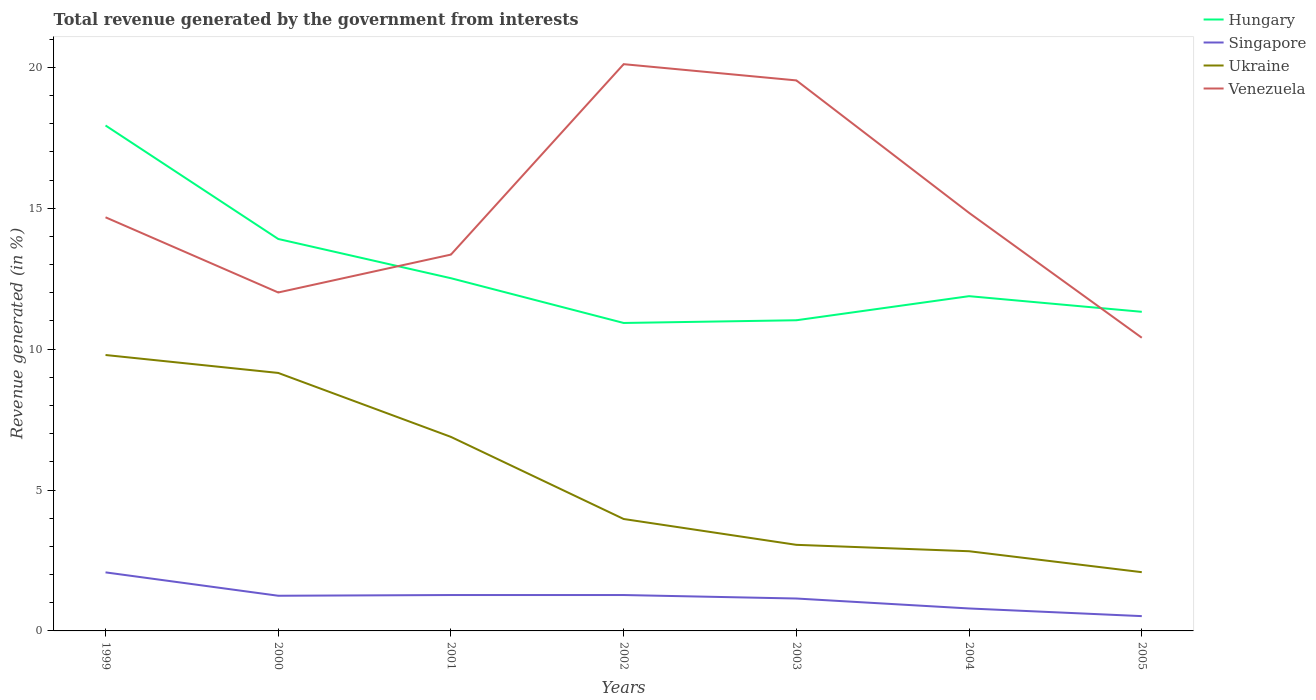How many different coloured lines are there?
Provide a succinct answer. 4. Is the number of lines equal to the number of legend labels?
Provide a succinct answer. Yes. Across all years, what is the maximum total revenue generated in Venezuela?
Ensure brevity in your answer.  10.4. In which year was the total revenue generated in Venezuela maximum?
Offer a terse response. 2005. What is the total total revenue generated in Singapore in the graph?
Keep it short and to the point. 0.35. What is the difference between the highest and the second highest total revenue generated in Ukraine?
Make the answer very short. 7.71. Is the total revenue generated in Singapore strictly greater than the total revenue generated in Hungary over the years?
Ensure brevity in your answer.  Yes. What is the difference between two consecutive major ticks on the Y-axis?
Make the answer very short. 5. Does the graph contain any zero values?
Provide a short and direct response. No. Does the graph contain grids?
Your answer should be compact. No. How many legend labels are there?
Offer a terse response. 4. What is the title of the graph?
Give a very brief answer. Total revenue generated by the government from interests. Does "Zambia" appear as one of the legend labels in the graph?
Your answer should be compact. No. What is the label or title of the Y-axis?
Your answer should be very brief. Revenue generated (in %). What is the Revenue generated (in %) of Hungary in 1999?
Offer a terse response. 17.94. What is the Revenue generated (in %) of Singapore in 1999?
Give a very brief answer. 2.08. What is the Revenue generated (in %) in Ukraine in 1999?
Your answer should be very brief. 9.79. What is the Revenue generated (in %) in Venezuela in 1999?
Your answer should be compact. 14.68. What is the Revenue generated (in %) of Hungary in 2000?
Give a very brief answer. 13.91. What is the Revenue generated (in %) in Singapore in 2000?
Provide a short and direct response. 1.25. What is the Revenue generated (in %) of Ukraine in 2000?
Ensure brevity in your answer.  9.15. What is the Revenue generated (in %) in Venezuela in 2000?
Keep it short and to the point. 12.01. What is the Revenue generated (in %) in Hungary in 2001?
Your answer should be very brief. 12.52. What is the Revenue generated (in %) of Singapore in 2001?
Offer a terse response. 1.27. What is the Revenue generated (in %) of Ukraine in 2001?
Give a very brief answer. 6.88. What is the Revenue generated (in %) of Venezuela in 2001?
Your answer should be compact. 13.35. What is the Revenue generated (in %) in Hungary in 2002?
Make the answer very short. 10.93. What is the Revenue generated (in %) in Singapore in 2002?
Offer a very short reply. 1.27. What is the Revenue generated (in %) in Ukraine in 2002?
Give a very brief answer. 3.97. What is the Revenue generated (in %) of Venezuela in 2002?
Give a very brief answer. 20.11. What is the Revenue generated (in %) in Hungary in 2003?
Keep it short and to the point. 11.02. What is the Revenue generated (in %) in Singapore in 2003?
Make the answer very short. 1.15. What is the Revenue generated (in %) in Ukraine in 2003?
Make the answer very short. 3.05. What is the Revenue generated (in %) of Venezuela in 2003?
Offer a terse response. 19.54. What is the Revenue generated (in %) in Hungary in 2004?
Your answer should be compact. 11.88. What is the Revenue generated (in %) in Singapore in 2004?
Make the answer very short. 0.8. What is the Revenue generated (in %) in Ukraine in 2004?
Your answer should be compact. 2.83. What is the Revenue generated (in %) of Venezuela in 2004?
Provide a succinct answer. 14.83. What is the Revenue generated (in %) in Hungary in 2005?
Provide a short and direct response. 11.32. What is the Revenue generated (in %) of Singapore in 2005?
Provide a short and direct response. 0.53. What is the Revenue generated (in %) of Ukraine in 2005?
Provide a succinct answer. 2.08. What is the Revenue generated (in %) in Venezuela in 2005?
Provide a short and direct response. 10.4. Across all years, what is the maximum Revenue generated (in %) of Hungary?
Provide a succinct answer. 17.94. Across all years, what is the maximum Revenue generated (in %) of Singapore?
Offer a very short reply. 2.08. Across all years, what is the maximum Revenue generated (in %) of Ukraine?
Offer a terse response. 9.79. Across all years, what is the maximum Revenue generated (in %) of Venezuela?
Offer a terse response. 20.11. Across all years, what is the minimum Revenue generated (in %) of Hungary?
Provide a succinct answer. 10.93. Across all years, what is the minimum Revenue generated (in %) of Singapore?
Your answer should be very brief. 0.53. Across all years, what is the minimum Revenue generated (in %) in Ukraine?
Your response must be concise. 2.08. Across all years, what is the minimum Revenue generated (in %) of Venezuela?
Keep it short and to the point. 10.4. What is the total Revenue generated (in %) in Hungary in the graph?
Offer a very short reply. 89.52. What is the total Revenue generated (in %) in Singapore in the graph?
Provide a succinct answer. 8.35. What is the total Revenue generated (in %) of Ukraine in the graph?
Your response must be concise. 37.77. What is the total Revenue generated (in %) of Venezuela in the graph?
Make the answer very short. 104.93. What is the difference between the Revenue generated (in %) of Hungary in 1999 and that in 2000?
Offer a terse response. 4.03. What is the difference between the Revenue generated (in %) in Singapore in 1999 and that in 2000?
Ensure brevity in your answer.  0.83. What is the difference between the Revenue generated (in %) in Ukraine in 1999 and that in 2000?
Ensure brevity in your answer.  0.64. What is the difference between the Revenue generated (in %) of Venezuela in 1999 and that in 2000?
Provide a succinct answer. 2.67. What is the difference between the Revenue generated (in %) in Hungary in 1999 and that in 2001?
Offer a very short reply. 5.42. What is the difference between the Revenue generated (in %) in Singapore in 1999 and that in 2001?
Ensure brevity in your answer.  0.8. What is the difference between the Revenue generated (in %) in Ukraine in 1999 and that in 2001?
Provide a succinct answer. 2.91. What is the difference between the Revenue generated (in %) of Venezuela in 1999 and that in 2001?
Make the answer very short. 1.32. What is the difference between the Revenue generated (in %) of Hungary in 1999 and that in 2002?
Your answer should be very brief. 7.01. What is the difference between the Revenue generated (in %) of Singapore in 1999 and that in 2002?
Offer a terse response. 0.8. What is the difference between the Revenue generated (in %) of Ukraine in 1999 and that in 2002?
Your answer should be very brief. 5.82. What is the difference between the Revenue generated (in %) in Venezuela in 1999 and that in 2002?
Provide a succinct answer. -5.43. What is the difference between the Revenue generated (in %) in Hungary in 1999 and that in 2003?
Your answer should be compact. 6.91. What is the difference between the Revenue generated (in %) in Singapore in 1999 and that in 2003?
Keep it short and to the point. 0.93. What is the difference between the Revenue generated (in %) of Ukraine in 1999 and that in 2003?
Offer a very short reply. 6.74. What is the difference between the Revenue generated (in %) in Venezuela in 1999 and that in 2003?
Provide a short and direct response. -4.86. What is the difference between the Revenue generated (in %) in Hungary in 1999 and that in 2004?
Give a very brief answer. 6.06. What is the difference between the Revenue generated (in %) in Singapore in 1999 and that in 2004?
Make the answer very short. 1.28. What is the difference between the Revenue generated (in %) in Ukraine in 1999 and that in 2004?
Keep it short and to the point. 6.96. What is the difference between the Revenue generated (in %) of Venezuela in 1999 and that in 2004?
Ensure brevity in your answer.  -0.16. What is the difference between the Revenue generated (in %) in Hungary in 1999 and that in 2005?
Make the answer very short. 6.61. What is the difference between the Revenue generated (in %) of Singapore in 1999 and that in 2005?
Make the answer very short. 1.55. What is the difference between the Revenue generated (in %) of Ukraine in 1999 and that in 2005?
Your answer should be compact. 7.71. What is the difference between the Revenue generated (in %) of Venezuela in 1999 and that in 2005?
Give a very brief answer. 4.27. What is the difference between the Revenue generated (in %) in Hungary in 2000 and that in 2001?
Ensure brevity in your answer.  1.39. What is the difference between the Revenue generated (in %) in Singapore in 2000 and that in 2001?
Ensure brevity in your answer.  -0.03. What is the difference between the Revenue generated (in %) of Ukraine in 2000 and that in 2001?
Provide a short and direct response. 2.27. What is the difference between the Revenue generated (in %) in Venezuela in 2000 and that in 2001?
Ensure brevity in your answer.  -1.34. What is the difference between the Revenue generated (in %) in Hungary in 2000 and that in 2002?
Offer a very short reply. 2.98. What is the difference between the Revenue generated (in %) in Singapore in 2000 and that in 2002?
Your answer should be very brief. -0.03. What is the difference between the Revenue generated (in %) in Ukraine in 2000 and that in 2002?
Keep it short and to the point. 5.18. What is the difference between the Revenue generated (in %) in Venezuela in 2000 and that in 2002?
Your answer should be very brief. -8.1. What is the difference between the Revenue generated (in %) in Hungary in 2000 and that in 2003?
Give a very brief answer. 2.88. What is the difference between the Revenue generated (in %) in Singapore in 2000 and that in 2003?
Ensure brevity in your answer.  0.1. What is the difference between the Revenue generated (in %) in Ukraine in 2000 and that in 2003?
Make the answer very short. 6.1. What is the difference between the Revenue generated (in %) in Venezuela in 2000 and that in 2003?
Your response must be concise. -7.53. What is the difference between the Revenue generated (in %) in Hungary in 2000 and that in 2004?
Your answer should be very brief. 2.03. What is the difference between the Revenue generated (in %) of Singapore in 2000 and that in 2004?
Your answer should be compact. 0.45. What is the difference between the Revenue generated (in %) of Ukraine in 2000 and that in 2004?
Provide a succinct answer. 6.33. What is the difference between the Revenue generated (in %) in Venezuela in 2000 and that in 2004?
Make the answer very short. -2.82. What is the difference between the Revenue generated (in %) in Hungary in 2000 and that in 2005?
Provide a succinct answer. 2.58. What is the difference between the Revenue generated (in %) in Singapore in 2000 and that in 2005?
Give a very brief answer. 0.72. What is the difference between the Revenue generated (in %) in Ukraine in 2000 and that in 2005?
Your answer should be very brief. 7.07. What is the difference between the Revenue generated (in %) of Venezuela in 2000 and that in 2005?
Make the answer very short. 1.61. What is the difference between the Revenue generated (in %) of Hungary in 2001 and that in 2002?
Your answer should be very brief. 1.59. What is the difference between the Revenue generated (in %) in Ukraine in 2001 and that in 2002?
Your answer should be compact. 2.91. What is the difference between the Revenue generated (in %) in Venezuela in 2001 and that in 2002?
Your answer should be compact. -6.76. What is the difference between the Revenue generated (in %) in Hungary in 2001 and that in 2003?
Keep it short and to the point. 1.49. What is the difference between the Revenue generated (in %) of Singapore in 2001 and that in 2003?
Your response must be concise. 0.12. What is the difference between the Revenue generated (in %) in Ukraine in 2001 and that in 2003?
Provide a succinct answer. 3.83. What is the difference between the Revenue generated (in %) of Venezuela in 2001 and that in 2003?
Make the answer very short. -6.18. What is the difference between the Revenue generated (in %) of Hungary in 2001 and that in 2004?
Your response must be concise. 0.64. What is the difference between the Revenue generated (in %) in Singapore in 2001 and that in 2004?
Your response must be concise. 0.48. What is the difference between the Revenue generated (in %) of Ukraine in 2001 and that in 2004?
Make the answer very short. 4.06. What is the difference between the Revenue generated (in %) of Venezuela in 2001 and that in 2004?
Your response must be concise. -1.48. What is the difference between the Revenue generated (in %) of Hungary in 2001 and that in 2005?
Your response must be concise. 1.19. What is the difference between the Revenue generated (in %) in Singapore in 2001 and that in 2005?
Keep it short and to the point. 0.75. What is the difference between the Revenue generated (in %) in Ukraine in 2001 and that in 2005?
Provide a short and direct response. 4.8. What is the difference between the Revenue generated (in %) of Venezuela in 2001 and that in 2005?
Your answer should be very brief. 2.95. What is the difference between the Revenue generated (in %) in Hungary in 2002 and that in 2003?
Offer a very short reply. -0.1. What is the difference between the Revenue generated (in %) in Singapore in 2002 and that in 2003?
Offer a very short reply. 0.12. What is the difference between the Revenue generated (in %) of Ukraine in 2002 and that in 2003?
Your response must be concise. 0.92. What is the difference between the Revenue generated (in %) in Venezuela in 2002 and that in 2003?
Offer a very short reply. 0.58. What is the difference between the Revenue generated (in %) of Hungary in 2002 and that in 2004?
Provide a short and direct response. -0.95. What is the difference between the Revenue generated (in %) of Singapore in 2002 and that in 2004?
Keep it short and to the point. 0.48. What is the difference between the Revenue generated (in %) in Ukraine in 2002 and that in 2004?
Your answer should be compact. 1.14. What is the difference between the Revenue generated (in %) of Venezuela in 2002 and that in 2004?
Your response must be concise. 5.28. What is the difference between the Revenue generated (in %) of Hungary in 2002 and that in 2005?
Your answer should be compact. -0.4. What is the difference between the Revenue generated (in %) of Singapore in 2002 and that in 2005?
Your response must be concise. 0.75. What is the difference between the Revenue generated (in %) of Ukraine in 2002 and that in 2005?
Give a very brief answer. 1.89. What is the difference between the Revenue generated (in %) of Venezuela in 2002 and that in 2005?
Ensure brevity in your answer.  9.71. What is the difference between the Revenue generated (in %) in Hungary in 2003 and that in 2004?
Offer a very short reply. -0.85. What is the difference between the Revenue generated (in %) in Singapore in 2003 and that in 2004?
Provide a succinct answer. 0.35. What is the difference between the Revenue generated (in %) in Ukraine in 2003 and that in 2004?
Make the answer very short. 0.23. What is the difference between the Revenue generated (in %) of Venezuela in 2003 and that in 2004?
Make the answer very short. 4.7. What is the difference between the Revenue generated (in %) of Hungary in 2003 and that in 2005?
Offer a very short reply. -0.3. What is the difference between the Revenue generated (in %) of Singapore in 2003 and that in 2005?
Offer a terse response. 0.62. What is the difference between the Revenue generated (in %) in Ukraine in 2003 and that in 2005?
Provide a succinct answer. 0.97. What is the difference between the Revenue generated (in %) in Venezuela in 2003 and that in 2005?
Keep it short and to the point. 9.13. What is the difference between the Revenue generated (in %) of Hungary in 2004 and that in 2005?
Ensure brevity in your answer.  0.55. What is the difference between the Revenue generated (in %) of Singapore in 2004 and that in 2005?
Keep it short and to the point. 0.27. What is the difference between the Revenue generated (in %) of Ukraine in 2004 and that in 2005?
Your response must be concise. 0.74. What is the difference between the Revenue generated (in %) of Venezuela in 2004 and that in 2005?
Ensure brevity in your answer.  4.43. What is the difference between the Revenue generated (in %) in Hungary in 1999 and the Revenue generated (in %) in Singapore in 2000?
Your response must be concise. 16.69. What is the difference between the Revenue generated (in %) of Hungary in 1999 and the Revenue generated (in %) of Ukraine in 2000?
Offer a very short reply. 8.78. What is the difference between the Revenue generated (in %) in Hungary in 1999 and the Revenue generated (in %) in Venezuela in 2000?
Your response must be concise. 5.93. What is the difference between the Revenue generated (in %) of Singapore in 1999 and the Revenue generated (in %) of Ukraine in 2000?
Provide a succinct answer. -7.08. What is the difference between the Revenue generated (in %) of Singapore in 1999 and the Revenue generated (in %) of Venezuela in 2000?
Provide a short and direct response. -9.93. What is the difference between the Revenue generated (in %) in Ukraine in 1999 and the Revenue generated (in %) in Venezuela in 2000?
Make the answer very short. -2.22. What is the difference between the Revenue generated (in %) of Hungary in 1999 and the Revenue generated (in %) of Singapore in 2001?
Give a very brief answer. 16.66. What is the difference between the Revenue generated (in %) of Hungary in 1999 and the Revenue generated (in %) of Ukraine in 2001?
Ensure brevity in your answer.  11.05. What is the difference between the Revenue generated (in %) of Hungary in 1999 and the Revenue generated (in %) of Venezuela in 2001?
Keep it short and to the point. 4.58. What is the difference between the Revenue generated (in %) of Singapore in 1999 and the Revenue generated (in %) of Ukraine in 2001?
Offer a very short reply. -4.81. What is the difference between the Revenue generated (in %) of Singapore in 1999 and the Revenue generated (in %) of Venezuela in 2001?
Provide a short and direct response. -11.28. What is the difference between the Revenue generated (in %) of Ukraine in 1999 and the Revenue generated (in %) of Venezuela in 2001?
Offer a terse response. -3.56. What is the difference between the Revenue generated (in %) of Hungary in 1999 and the Revenue generated (in %) of Singapore in 2002?
Provide a short and direct response. 16.66. What is the difference between the Revenue generated (in %) of Hungary in 1999 and the Revenue generated (in %) of Ukraine in 2002?
Your answer should be compact. 13.96. What is the difference between the Revenue generated (in %) of Hungary in 1999 and the Revenue generated (in %) of Venezuela in 2002?
Your answer should be very brief. -2.18. What is the difference between the Revenue generated (in %) of Singapore in 1999 and the Revenue generated (in %) of Ukraine in 2002?
Offer a very short reply. -1.89. What is the difference between the Revenue generated (in %) in Singapore in 1999 and the Revenue generated (in %) in Venezuela in 2002?
Provide a short and direct response. -18.03. What is the difference between the Revenue generated (in %) of Ukraine in 1999 and the Revenue generated (in %) of Venezuela in 2002?
Offer a very short reply. -10.32. What is the difference between the Revenue generated (in %) in Hungary in 1999 and the Revenue generated (in %) in Singapore in 2003?
Your response must be concise. 16.79. What is the difference between the Revenue generated (in %) in Hungary in 1999 and the Revenue generated (in %) in Ukraine in 2003?
Give a very brief answer. 14.88. What is the difference between the Revenue generated (in %) in Hungary in 1999 and the Revenue generated (in %) in Venezuela in 2003?
Keep it short and to the point. -1.6. What is the difference between the Revenue generated (in %) of Singapore in 1999 and the Revenue generated (in %) of Ukraine in 2003?
Offer a terse response. -0.98. What is the difference between the Revenue generated (in %) of Singapore in 1999 and the Revenue generated (in %) of Venezuela in 2003?
Your answer should be very brief. -17.46. What is the difference between the Revenue generated (in %) in Ukraine in 1999 and the Revenue generated (in %) in Venezuela in 2003?
Your answer should be compact. -9.74. What is the difference between the Revenue generated (in %) in Hungary in 1999 and the Revenue generated (in %) in Singapore in 2004?
Give a very brief answer. 17.14. What is the difference between the Revenue generated (in %) in Hungary in 1999 and the Revenue generated (in %) in Ukraine in 2004?
Provide a short and direct response. 15.11. What is the difference between the Revenue generated (in %) in Hungary in 1999 and the Revenue generated (in %) in Venezuela in 2004?
Your answer should be very brief. 3.1. What is the difference between the Revenue generated (in %) of Singapore in 1999 and the Revenue generated (in %) of Ukraine in 2004?
Provide a short and direct response. -0.75. What is the difference between the Revenue generated (in %) in Singapore in 1999 and the Revenue generated (in %) in Venezuela in 2004?
Give a very brief answer. -12.76. What is the difference between the Revenue generated (in %) of Ukraine in 1999 and the Revenue generated (in %) of Venezuela in 2004?
Keep it short and to the point. -5.04. What is the difference between the Revenue generated (in %) in Hungary in 1999 and the Revenue generated (in %) in Singapore in 2005?
Your response must be concise. 17.41. What is the difference between the Revenue generated (in %) of Hungary in 1999 and the Revenue generated (in %) of Ukraine in 2005?
Your response must be concise. 15.85. What is the difference between the Revenue generated (in %) of Hungary in 1999 and the Revenue generated (in %) of Venezuela in 2005?
Keep it short and to the point. 7.53. What is the difference between the Revenue generated (in %) in Singapore in 1999 and the Revenue generated (in %) in Ukraine in 2005?
Ensure brevity in your answer.  -0.01. What is the difference between the Revenue generated (in %) of Singapore in 1999 and the Revenue generated (in %) of Venezuela in 2005?
Give a very brief answer. -8.33. What is the difference between the Revenue generated (in %) in Ukraine in 1999 and the Revenue generated (in %) in Venezuela in 2005?
Your answer should be compact. -0.61. What is the difference between the Revenue generated (in %) in Hungary in 2000 and the Revenue generated (in %) in Singapore in 2001?
Keep it short and to the point. 12.63. What is the difference between the Revenue generated (in %) of Hungary in 2000 and the Revenue generated (in %) of Ukraine in 2001?
Make the answer very short. 7.02. What is the difference between the Revenue generated (in %) of Hungary in 2000 and the Revenue generated (in %) of Venezuela in 2001?
Your answer should be very brief. 0.55. What is the difference between the Revenue generated (in %) in Singapore in 2000 and the Revenue generated (in %) in Ukraine in 2001?
Give a very brief answer. -5.64. What is the difference between the Revenue generated (in %) in Singapore in 2000 and the Revenue generated (in %) in Venezuela in 2001?
Provide a succinct answer. -12.11. What is the difference between the Revenue generated (in %) of Hungary in 2000 and the Revenue generated (in %) of Singapore in 2002?
Your answer should be compact. 12.63. What is the difference between the Revenue generated (in %) in Hungary in 2000 and the Revenue generated (in %) in Ukraine in 2002?
Keep it short and to the point. 9.94. What is the difference between the Revenue generated (in %) of Hungary in 2000 and the Revenue generated (in %) of Venezuela in 2002?
Your response must be concise. -6.2. What is the difference between the Revenue generated (in %) in Singapore in 2000 and the Revenue generated (in %) in Ukraine in 2002?
Make the answer very short. -2.72. What is the difference between the Revenue generated (in %) of Singapore in 2000 and the Revenue generated (in %) of Venezuela in 2002?
Your answer should be very brief. -18.86. What is the difference between the Revenue generated (in %) in Ukraine in 2000 and the Revenue generated (in %) in Venezuela in 2002?
Provide a short and direct response. -10.96. What is the difference between the Revenue generated (in %) in Hungary in 2000 and the Revenue generated (in %) in Singapore in 2003?
Offer a terse response. 12.76. What is the difference between the Revenue generated (in %) in Hungary in 2000 and the Revenue generated (in %) in Ukraine in 2003?
Your answer should be very brief. 10.85. What is the difference between the Revenue generated (in %) in Hungary in 2000 and the Revenue generated (in %) in Venezuela in 2003?
Provide a short and direct response. -5.63. What is the difference between the Revenue generated (in %) in Singapore in 2000 and the Revenue generated (in %) in Ukraine in 2003?
Give a very brief answer. -1.81. What is the difference between the Revenue generated (in %) in Singapore in 2000 and the Revenue generated (in %) in Venezuela in 2003?
Ensure brevity in your answer.  -18.29. What is the difference between the Revenue generated (in %) in Ukraine in 2000 and the Revenue generated (in %) in Venezuela in 2003?
Your answer should be very brief. -10.38. What is the difference between the Revenue generated (in %) in Hungary in 2000 and the Revenue generated (in %) in Singapore in 2004?
Make the answer very short. 13.11. What is the difference between the Revenue generated (in %) in Hungary in 2000 and the Revenue generated (in %) in Ukraine in 2004?
Ensure brevity in your answer.  11.08. What is the difference between the Revenue generated (in %) of Hungary in 2000 and the Revenue generated (in %) of Venezuela in 2004?
Make the answer very short. -0.93. What is the difference between the Revenue generated (in %) of Singapore in 2000 and the Revenue generated (in %) of Ukraine in 2004?
Provide a succinct answer. -1.58. What is the difference between the Revenue generated (in %) of Singapore in 2000 and the Revenue generated (in %) of Venezuela in 2004?
Your response must be concise. -13.59. What is the difference between the Revenue generated (in %) in Ukraine in 2000 and the Revenue generated (in %) in Venezuela in 2004?
Keep it short and to the point. -5.68. What is the difference between the Revenue generated (in %) in Hungary in 2000 and the Revenue generated (in %) in Singapore in 2005?
Your answer should be compact. 13.38. What is the difference between the Revenue generated (in %) of Hungary in 2000 and the Revenue generated (in %) of Ukraine in 2005?
Provide a succinct answer. 11.82. What is the difference between the Revenue generated (in %) in Hungary in 2000 and the Revenue generated (in %) in Venezuela in 2005?
Provide a short and direct response. 3.5. What is the difference between the Revenue generated (in %) of Singapore in 2000 and the Revenue generated (in %) of Ukraine in 2005?
Your answer should be very brief. -0.84. What is the difference between the Revenue generated (in %) of Singapore in 2000 and the Revenue generated (in %) of Venezuela in 2005?
Your answer should be compact. -9.16. What is the difference between the Revenue generated (in %) of Ukraine in 2000 and the Revenue generated (in %) of Venezuela in 2005?
Give a very brief answer. -1.25. What is the difference between the Revenue generated (in %) of Hungary in 2001 and the Revenue generated (in %) of Singapore in 2002?
Your response must be concise. 11.24. What is the difference between the Revenue generated (in %) of Hungary in 2001 and the Revenue generated (in %) of Ukraine in 2002?
Provide a succinct answer. 8.54. What is the difference between the Revenue generated (in %) of Hungary in 2001 and the Revenue generated (in %) of Venezuela in 2002?
Give a very brief answer. -7.6. What is the difference between the Revenue generated (in %) in Singapore in 2001 and the Revenue generated (in %) in Ukraine in 2002?
Offer a very short reply. -2.7. What is the difference between the Revenue generated (in %) of Singapore in 2001 and the Revenue generated (in %) of Venezuela in 2002?
Make the answer very short. -18.84. What is the difference between the Revenue generated (in %) of Ukraine in 2001 and the Revenue generated (in %) of Venezuela in 2002?
Offer a terse response. -13.23. What is the difference between the Revenue generated (in %) in Hungary in 2001 and the Revenue generated (in %) in Singapore in 2003?
Offer a very short reply. 11.37. What is the difference between the Revenue generated (in %) of Hungary in 2001 and the Revenue generated (in %) of Ukraine in 2003?
Give a very brief answer. 9.46. What is the difference between the Revenue generated (in %) in Hungary in 2001 and the Revenue generated (in %) in Venezuela in 2003?
Your response must be concise. -7.02. What is the difference between the Revenue generated (in %) of Singapore in 2001 and the Revenue generated (in %) of Ukraine in 2003?
Give a very brief answer. -1.78. What is the difference between the Revenue generated (in %) in Singapore in 2001 and the Revenue generated (in %) in Venezuela in 2003?
Keep it short and to the point. -18.26. What is the difference between the Revenue generated (in %) of Ukraine in 2001 and the Revenue generated (in %) of Venezuela in 2003?
Your response must be concise. -12.65. What is the difference between the Revenue generated (in %) in Hungary in 2001 and the Revenue generated (in %) in Singapore in 2004?
Provide a succinct answer. 11.72. What is the difference between the Revenue generated (in %) in Hungary in 2001 and the Revenue generated (in %) in Ukraine in 2004?
Make the answer very short. 9.69. What is the difference between the Revenue generated (in %) in Hungary in 2001 and the Revenue generated (in %) in Venezuela in 2004?
Your response must be concise. -2.32. What is the difference between the Revenue generated (in %) in Singapore in 2001 and the Revenue generated (in %) in Ukraine in 2004?
Your response must be concise. -1.55. What is the difference between the Revenue generated (in %) in Singapore in 2001 and the Revenue generated (in %) in Venezuela in 2004?
Your answer should be compact. -13.56. What is the difference between the Revenue generated (in %) in Ukraine in 2001 and the Revenue generated (in %) in Venezuela in 2004?
Your response must be concise. -7.95. What is the difference between the Revenue generated (in %) of Hungary in 2001 and the Revenue generated (in %) of Singapore in 2005?
Your response must be concise. 11.99. What is the difference between the Revenue generated (in %) in Hungary in 2001 and the Revenue generated (in %) in Ukraine in 2005?
Provide a succinct answer. 10.43. What is the difference between the Revenue generated (in %) in Hungary in 2001 and the Revenue generated (in %) in Venezuela in 2005?
Provide a short and direct response. 2.11. What is the difference between the Revenue generated (in %) of Singapore in 2001 and the Revenue generated (in %) of Ukraine in 2005?
Give a very brief answer. -0.81. What is the difference between the Revenue generated (in %) in Singapore in 2001 and the Revenue generated (in %) in Venezuela in 2005?
Your answer should be very brief. -9.13. What is the difference between the Revenue generated (in %) of Ukraine in 2001 and the Revenue generated (in %) of Venezuela in 2005?
Provide a succinct answer. -3.52. What is the difference between the Revenue generated (in %) in Hungary in 2002 and the Revenue generated (in %) in Singapore in 2003?
Make the answer very short. 9.78. What is the difference between the Revenue generated (in %) in Hungary in 2002 and the Revenue generated (in %) in Ukraine in 2003?
Your response must be concise. 7.87. What is the difference between the Revenue generated (in %) in Hungary in 2002 and the Revenue generated (in %) in Venezuela in 2003?
Offer a terse response. -8.61. What is the difference between the Revenue generated (in %) in Singapore in 2002 and the Revenue generated (in %) in Ukraine in 2003?
Provide a succinct answer. -1.78. What is the difference between the Revenue generated (in %) in Singapore in 2002 and the Revenue generated (in %) in Venezuela in 2003?
Ensure brevity in your answer.  -18.26. What is the difference between the Revenue generated (in %) in Ukraine in 2002 and the Revenue generated (in %) in Venezuela in 2003?
Make the answer very short. -15.56. What is the difference between the Revenue generated (in %) of Hungary in 2002 and the Revenue generated (in %) of Singapore in 2004?
Provide a short and direct response. 10.13. What is the difference between the Revenue generated (in %) of Hungary in 2002 and the Revenue generated (in %) of Venezuela in 2004?
Offer a terse response. -3.91. What is the difference between the Revenue generated (in %) in Singapore in 2002 and the Revenue generated (in %) in Ukraine in 2004?
Provide a short and direct response. -1.55. What is the difference between the Revenue generated (in %) of Singapore in 2002 and the Revenue generated (in %) of Venezuela in 2004?
Provide a short and direct response. -13.56. What is the difference between the Revenue generated (in %) of Ukraine in 2002 and the Revenue generated (in %) of Venezuela in 2004?
Your answer should be very brief. -10.86. What is the difference between the Revenue generated (in %) of Hungary in 2002 and the Revenue generated (in %) of Singapore in 2005?
Make the answer very short. 10.4. What is the difference between the Revenue generated (in %) in Hungary in 2002 and the Revenue generated (in %) in Ukraine in 2005?
Ensure brevity in your answer.  8.84. What is the difference between the Revenue generated (in %) of Hungary in 2002 and the Revenue generated (in %) of Venezuela in 2005?
Your answer should be compact. 0.52. What is the difference between the Revenue generated (in %) in Singapore in 2002 and the Revenue generated (in %) in Ukraine in 2005?
Provide a short and direct response. -0.81. What is the difference between the Revenue generated (in %) in Singapore in 2002 and the Revenue generated (in %) in Venezuela in 2005?
Provide a short and direct response. -9.13. What is the difference between the Revenue generated (in %) in Ukraine in 2002 and the Revenue generated (in %) in Venezuela in 2005?
Keep it short and to the point. -6.43. What is the difference between the Revenue generated (in %) of Hungary in 2003 and the Revenue generated (in %) of Singapore in 2004?
Keep it short and to the point. 10.23. What is the difference between the Revenue generated (in %) of Hungary in 2003 and the Revenue generated (in %) of Ukraine in 2004?
Your response must be concise. 8.2. What is the difference between the Revenue generated (in %) in Hungary in 2003 and the Revenue generated (in %) in Venezuela in 2004?
Provide a short and direct response. -3.81. What is the difference between the Revenue generated (in %) of Singapore in 2003 and the Revenue generated (in %) of Ukraine in 2004?
Your answer should be compact. -1.68. What is the difference between the Revenue generated (in %) in Singapore in 2003 and the Revenue generated (in %) in Venezuela in 2004?
Provide a succinct answer. -13.68. What is the difference between the Revenue generated (in %) of Ukraine in 2003 and the Revenue generated (in %) of Venezuela in 2004?
Offer a very short reply. -11.78. What is the difference between the Revenue generated (in %) in Hungary in 2003 and the Revenue generated (in %) in Singapore in 2005?
Your response must be concise. 10.5. What is the difference between the Revenue generated (in %) of Hungary in 2003 and the Revenue generated (in %) of Ukraine in 2005?
Offer a terse response. 8.94. What is the difference between the Revenue generated (in %) in Hungary in 2003 and the Revenue generated (in %) in Venezuela in 2005?
Offer a very short reply. 0.62. What is the difference between the Revenue generated (in %) in Singapore in 2003 and the Revenue generated (in %) in Ukraine in 2005?
Ensure brevity in your answer.  -0.93. What is the difference between the Revenue generated (in %) of Singapore in 2003 and the Revenue generated (in %) of Venezuela in 2005?
Your answer should be very brief. -9.25. What is the difference between the Revenue generated (in %) of Ukraine in 2003 and the Revenue generated (in %) of Venezuela in 2005?
Your answer should be compact. -7.35. What is the difference between the Revenue generated (in %) in Hungary in 2004 and the Revenue generated (in %) in Singapore in 2005?
Your response must be concise. 11.35. What is the difference between the Revenue generated (in %) in Hungary in 2004 and the Revenue generated (in %) in Ukraine in 2005?
Provide a short and direct response. 9.79. What is the difference between the Revenue generated (in %) in Hungary in 2004 and the Revenue generated (in %) in Venezuela in 2005?
Your answer should be compact. 1.48. What is the difference between the Revenue generated (in %) of Singapore in 2004 and the Revenue generated (in %) of Ukraine in 2005?
Offer a terse response. -1.29. What is the difference between the Revenue generated (in %) in Singapore in 2004 and the Revenue generated (in %) in Venezuela in 2005?
Provide a short and direct response. -9.61. What is the difference between the Revenue generated (in %) in Ukraine in 2004 and the Revenue generated (in %) in Venezuela in 2005?
Offer a very short reply. -7.58. What is the average Revenue generated (in %) of Hungary per year?
Your answer should be very brief. 12.79. What is the average Revenue generated (in %) of Singapore per year?
Give a very brief answer. 1.19. What is the average Revenue generated (in %) in Ukraine per year?
Offer a terse response. 5.4. What is the average Revenue generated (in %) of Venezuela per year?
Offer a terse response. 14.99. In the year 1999, what is the difference between the Revenue generated (in %) of Hungary and Revenue generated (in %) of Singapore?
Give a very brief answer. 15.86. In the year 1999, what is the difference between the Revenue generated (in %) in Hungary and Revenue generated (in %) in Ukraine?
Offer a terse response. 8.15. In the year 1999, what is the difference between the Revenue generated (in %) of Hungary and Revenue generated (in %) of Venezuela?
Offer a very short reply. 3.26. In the year 1999, what is the difference between the Revenue generated (in %) in Singapore and Revenue generated (in %) in Ukraine?
Provide a succinct answer. -7.71. In the year 1999, what is the difference between the Revenue generated (in %) in Singapore and Revenue generated (in %) in Venezuela?
Provide a succinct answer. -12.6. In the year 1999, what is the difference between the Revenue generated (in %) of Ukraine and Revenue generated (in %) of Venezuela?
Provide a short and direct response. -4.89. In the year 2000, what is the difference between the Revenue generated (in %) of Hungary and Revenue generated (in %) of Singapore?
Ensure brevity in your answer.  12.66. In the year 2000, what is the difference between the Revenue generated (in %) of Hungary and Revenue generated (in %) of Ukraine?
Your answer should be very brief. 4.75. In the year 2000, what is the difference between the Revenue generated (in %) of Hungary and Revenue generated (in %) of Venezuela?
Give a very brief answer. 1.9. In the year 2000, what is the difference between the Revenue generated (in %) in Singapore and Revenue generated (in %) in Ukraine?
Make the answer very short. -7.91. In the year 2000, what is the difference between the Revenue generated (in %) of Singapore and Revenue generated (in %) of Venezuela?
Your answer should be compact. -10.76. In the year 2000, what is the difference between the Revenue generated (in %) of Ukraine and Revenue generated (in %) of Venezuela?
Your response must be concise. -2.86. In the year 2001, what is the difference between the Revenue generated (in %) in Hungary and Revenue generated (in %) in Singapore?
Provide a short and direct response. 11.24. In the year 2001, what is the difference between the Revenue generated (in %) in Hungary and Revenue generated (in %) in Ukraine?
Your answer should be very brief. 5.63. In the year 2001, what is the difference between the Revenue generated (in %) of Hungary and Revenue generated (in %) of Venezuela?
Ensure brevity in your answer.  -0.84. In the year 2001, what is the difference between the Revenue generated (in %) of Singapore and Revenue generated (in %) of Ukraine?
Keep it short and to the point. -5.61. In the year 2001, what is the difference between the Revenue generated (in %) in Singapore and Revenue generated (in %) in Venezuela?
Keep it short and to the point. -12.08. In the year 2001, what is the difference between the Revenue generated (in %) in Ukraine and Revenue generated (in %) in Venezuela?
Offer a terse response. -6.47. In the year 2002, what is the difference between the Revenue generated (in %) in Hungary and Revenue generated (in %) in Singapore?
Provide a short and direct response. 9.65. In the year 2002, what is the difference between the Revenue generated (in %) of Hungary and Revenue generated (in %) of Ukraine?
Your response must be concise. 6.96. In the year 2002, what is the difference between the Revenue generated (in %) of Hungary and Revenue generated (in %) of Venezuela?
Provide a succinct answer. -9.18. In the year 2002, what is the difference between the Revenue generated (in %) of Singapore and Revenue generated (in %) of Ukraine?
Provide a succinct answer. -2.7. In the year 2002, what is the difference between the Revenue generated (in %) in Singapore and Revenue generated (in %) in Venezuela?
Offer a very short reply. -18.84. In the year 2002, what is the difference between the Revenue generated (in %) in Ukraine and Revenue generated (in %) in Venezuela?
Give a very brief answer. -16.14. In the year 2003, what is the difference between the Revenue generated (in %) in Hungary and Revenue generated (in %) in Singapore?
Your response must be concise. 9.87. In the year 2003, what is the difference between the Revenue generated (in %) in Hungary and Revenue generated (in %) in Ukraine?
Your answer should be very brief. 7.97. In the year 2003, what is the difference between the Revenue generated (in %) in Hungary and Revenue generated (in %) in Venezuela?
Offer a terse response. -8.51. In the year 2003, what is the difference between the Revenue generated (in %) in Singapore and Revenue generated (in %) in Ukraine?
Keep it short and to the point. -1.91. In the year 2003, what is the difference between the Revenue generated (in %) in Singapore and Revenue generated (in %) in Venezuela?
Keep it short and to the point. -18.39. In the year 2003, what is the difference between the Revenue generated (in %) of Ukraine and Revenue generated (in %) of Venezuela?
Ensure brevity in your answer.  -16.48. In the year 2004, what is the difference between the Revenue generated (in %) of Hungary and Revenue generated (in %) of Singapore?
Your answer should be very brief. 11.08. In the year 2004, what is the difference between the Revenue generated (in %) of Hungary and Revenue generated (in %) of Ukraine?
Keep it short and to the point. 9.05. In the year 2004, what is the difference between the Revenue generated (in %) in Hungary and Revenue generated (in %) in Venezuela?
Offer a very short reply. -2.96. In the year 2004, what is the difference between the Revenue generated (in %) in Singapore and Revenue generated (in %) in Ukraine?
Your answer should be very brief. -2.03. In the year 2004, what is the difference between the Revenue generated (in %) in Singapore and Revenue generated (in %) in Venezuela?
Your response must be concise. -14.04. In the year 2004, what is the difference between the Revenue generated (in %) in Ukraine and Revenue generated (in %) in Venezuela?
Give a very brief answer. -12.01. In the year 2005, what is the difference between the Revenue generated (in %) in Hungary and Revenue generated (in %) in Singapore?
Your answer should be compact. 10.8. In the year 2005, what is the difference between the Revenue generated (in %) in Hungary and Revenue generated (in %) in Ukraine?
Give a very brief answer. 9.24. In the year 2005, what is the difference between the Revenue generated (in %) of Hungary and Revenue generated (in %) of Venezuela?
Offer a very short reply. 0.92. In the year 2005, what is the difference between the Revenue generated (in %) in Singapore and Revenue generated (in %) in Ukraine?
Ensure brevity in your answer.  -1.56. In the year 2005, what is the difference between the Revenue generated (in %) in Singapore and Revenue generated (in %) in Venezuela?
Keep it short and to the point. -9.88. In the year 2005, what is the difference between the Revenue generated (in %) of Ukraine and Revenue generated (in %) of Venezuela?
Offer a terse response. -8.32. What is the ratio of the Revenue generated (in %) of Hungary in 1999 to that in 2000?
Your response must be concise. 1.29. What is the ratio of the Revenue generated (in %) of Singapore in 1999 to that in 2000?
Provide a short and direct response. 1.66. What is the ratio of the Revenue generated (in %) in Ukraine in 1999 to that in 2000?
Ensure brevity in your answer.  1.07. What is the ratio of the Revenue generated (in %) in Venezuela in 1999 to that in 2000?
Keep it short and to the point. 1.22. What is the ratio of the Revenue generated (in %) of Hungary in 1999 to that in 2001?
Ensure brevity in your answer.  1.43. What is the ratio of the Revenue generated (in %) in Singapore in 1999 to that in 2001?
Ensure brevity in your answer.  1.63. What is the ratio of the Revenue generated (in %) of Ukraine in 1999 to that in 2001?
Provide a short and direct response. 1.42. What is the ratio of the Revenue generated (in %) of Venezuela in 1999 to that in 2001?
Provide a succinct answer. 1.1. What is the ratio of the Revenue generated (in %) of Hungary in 1999 to that in 2002?
Give a very brief answer. 1.64. What is the ratio of the Revenue generated (in %) of Singapore in 1999 to that in 2002?
Provide a succinct answer. 1.63. What is the ratio of the Revenue generated (in %) of Ukraine in 1999 to that in 2002?
Make the answer very short. 2.47. What is the ratio of the Revenue generated (in %) of Venezuela in 1999 to that in 2002?
Offer a very short reply. 0.73. What is the ratio of the Revenue generated (in %) of Hungary in 1999 to that in 2003?
Provide a succinct answer. 1.63. What is the ratio of the Revenue generated (in %) in Singapore in 1999 to that in 2003?
Your answer should be compact. 1.81. What is the ratio of the Revenue generated (in %) of Ukraine in 1999 to that in 2003?
Offer a very short reply. 3.2. What is the ratio of the Revenue generated (in %) in Venezuela in 1999 to that in 2003?
Keep it short and to the point. 0.75. What is the ratio of the Revenue generated (in %) of Hungary in 1999 to that in 2004?
Your answer should be compact. 1.51. What is the ratio of the Revenue generated (in %) in Singapore in 1999 to that in 2004?
Offer a terse response. 2.61. What is the ratio of the Revenue generated (in %) in Ukraine in 1999 to that in 2004?
Offer a very short reply. 3.46. What is the ratio of the Revenue generated (in %) in Hungary in 1999 to that in 2005?
Make the answer very short. 1.58. What is the ratio of the Revenue generated (in %) in Singapore in 1999 to that in 2005?
Make the answer very short. 3.96. What is the ratio of the Revenue generated (in %) in Ukraine in 1999 to that in 2005?
Keep it short and to the point. 4.7. What is the ratio of the Revenue generated (in %) in Venezuela in 1999 to that in 2005?
Make the answer very short. 1.41. What is the ratio of the Revenue generated (in %) of Hungary in 2000 to that in 2001?
Offer a terse response. 1.11. What is the ratio of the Revenue generated (in %) in Singapore in 2000 to that in 2001?
Your response must be concise. 0.98. What is the ratio of the Revenue generated (in %) of Ukraine in 2000 to that in 2001?
Offer a very short reply. 1.33. What is the ratio of the Revenue generated (in %) in Venezuela in 2000 to that in 2001?
Provide a short and direct response. 0.9. What is the ratio of the Revenue generated (in %) of Hungary in 2000 to that in 2002?
Give a very brief answer. 1.27. What is the ratio of the Revenue generated (in %) in Singapore in 2000 to that in 2002?
Make the answer very short. 0.98. What is the ratio of the Revenue generated (in %) in Ukraine in 2000 to that in 2002?
Your response must be concise. 2.31. What is the ratio of the Revenue generated (in %) of Venezuela in 2000 to that in 2002?
Make the answer very short. 0.6. What is the ratio of the Revenue generated (in %) of Hungary in 2000 to that in 2003?
Keep it short and to the point. 1.26. What is the ratio of the Revenue generated (in %) in Singapore in 2000 to that in 2003?
Provide a short and direct response. 1.09. What is the ratio of the Revenue generated (in %) in Ukraine in 2000 to that in 2003?
Ensure brevity in your answer.  3. What is the ratio of the Revenue generated (in %) in Venezuela in 2000 to that in 2003?
Your response must be concise. 0.61. What is the ratio of the Revenue generated (in %) of Hungary in 2000 to that in 2004?
Offer a terse response. 1.17. What is the ratio of the Revenue generated (in %) of Singapore in 2000 to that in 2004?
Offer a terse response. 1.57. What is the ratio of the Revenue generated (in %) of Ukraine in 2000 to that in 2004?
Your response must be concise. 3.24. What is the ratio of the Revenue generated (in %) in Venezuela in 2000 to that in 2004?
Your answer should be compact. 0.81. What is the ratio of the Revenue generated (in %) of Hungary in 2000 to that in 2005?
Provide a short and direct response. 1.23. What is the ratio of the Revenue generated (in %) of Singapore in 2000 to that in 2005?
Offer a terse response. 2.38. What is the ratio of the Revenue generated (in %) in Ukraine in 2000 to that in 2005?
Your answer should be very brief. 4.39. What is the ratio of the Revenue generated (in %) in Venezuela in 2000 to that in 2005?
Offer a terse response. 1.15. What is the ratio of the Revenue generated (in %) of Hungary in 2001 to that in 2002?
Provide a short and direct response. 1.15. What is the ratio of the Revenue generated (in %) of Singapore in 2001 to that in 2002?
Ensure brevity in your answer.  1. What is the ratio of the Revenue generated (in %) of Ukraine in 2001 to that in 2002?
Your answer should be very brief. 1.73. What is the ratio of the Revenue generated (in %) of Venezuela in 2001 to that in 2002?
Make the answer very short. 0.66. What is the ratio of the Revenue generated (in %) of Hungary in 2001 to that in 2003?
Provide a short and direct response. 1.14. What is the ratio of the Revenue generated (in %) in Singapore in 2001 to that in 2003?
Your response must be concise. 1.11. What is the ratio of the Revenue generated (in %) of Ukraine in 2001 to that in 2003?
Offer a terse response. 2.25. What is the ratio of the Revenue generated (in %) in Venezuela in 2001 to that in 2003?
Provide a succinct answer. 0.68. What is the ratio of the Revenue generated (in %) of Hungary in 2001 to that in 2004?
Your response must be concise. 1.05. What is the ratio of the Revenue generated (in %) of Singapore in 2001 to that in 2004?
Your answer should be very brief. 1.6. What is the ratio of the Revenue generated (in %) in Ukraine in 2001 to that in 2004?
Your response must be concise. 2.43. What is the ratio of the Revenue generated (in %) of Venezuela in 2001 to that in 2004?
Make the answer very short. 0.9. What is the ratio of the Revenue generated (in %) of Hungary in 2001 to that in 2005?
Give a very brief answer. 1.11. What is the ratio of the Revenue generated (in %) in Singapore in 2001 to that in 2005?
Ensure brevity in your answer.  2.43. What is the ratio of the Revenue generated (in %) in Ukraine in 2001 to that in 2005?
Offer a very short reply. 3.3. What is the ratio of the Revenue generated (in %) in Venezuela in 2001 to that in 2005?
Ensure brevity in your answer.  1.28. What is the ratio of the Revenue generated (in %) in Hungary in 2002 to that in 2003?
Keep it short and to the point. 0.99. What is the ratio of the Revenue generated (in %) of Singapore in 2002 to that in 2003?
Keep it short and to the point. 1.11. What is the ratio of the Revenue generated (in %) of Ukraine in 2002 to that in 2003?
Your answer should be compact. 1.3. What is the ratio of the Revenue generated (in %) of Venezuela in 2002 to that in 2003?
Offer a terse response. 1.03. What is the ratio of the Revenue generated (in %) in Hungary in 2002 to that in 2004?
Offer a terse response. 0.92. What is the ratio of the Revenue generated (in %) of Singapore in 2002 to that in 2004?
Make the answer very short. 1.6. What is the ratio of the Revenue generated (in %) of Ukraine in 2002 to that in 2004?
Your answer should be compact. 1.4. What is the ratio of the Revenue generated (in %) in Venezuela in 2002 to that in 2004?
Make the answer very short. 1.36. What is the ratio of the Revenue generated (in %) in Hungary in 2002 to that in 2005?
Keep it short and to the point. 0.96. What is the ratio of the Revenue generated (in %) of Singapore in 2002 to that in 2005?
Make the answer very short. 2.43. What is the ratio of the Revenue generated (in %) of Ukraine in 2002 to that in 2005?
Ensure brevity in your answer.  1.91. What is the ratio of the Revenue generated (in %) in Venezuela in 2002 to that in 2005?
Make the answer very short. 1.93. What is the ratio of the Revenue generated (in %) of Hungary in 2003 to that in 2004?
Give a very brief answer. 0.93. What is the ratio of the Revenue generated (in %) of Singapore in 2003 to that in 2004?
Give a very brief answer. 1.44. What is the ratio of the Revenue generated (in %) in Ukraine in 2003 to that in 2004?
Offer a very short reply. 1.08. What is the ratio of the Revenue generated (in %) of Venezuela in 2003 to that in 2004?
Ensure brevity in your answer.  1.32. What is the ratio of the Revenue generated (in %) of Hungary in 2003 to that in 2005?
Offer a terse response. 0.97. What is the ratio of the Revenue generated (in %) in Singapore in 2003 to that in 2005?
Your answer should be compact. 2.19. What is the ratio of the Revenue generated (in %) in Ukraine in 2003 to that in 2005?
Offer a terse response. 1.47. What is the ratio of the Revenue generated (in %) in Venezuela in 2003 to that in 2005?
Give a very brief answer. 1.88. What is the ratio of the Revenue generated (in %) in Hungary in 2004 to that in 2005?
Provide a short and direct response. 1.05. What is the ratio of the Revenue generated (in %) in Singapore in 2004 to that in 2005?
Offer a terse response. 1.52. What is the ratio of the Revenue generated (in %) of Ukraine in 2004 to that in 2005?
Ensure brevity in your answer.  1.36. What is the ratio of the Revenue generated (in %) of Venezuela in 2004 to that in 2005?
Offer a very short reply. 1.43. What is the difference between the highest and the second highest Revenue generated (in %) of Hungary?
Provide a succinct answer. 4.03. What is the difference between the highest and the second highest Revenue generated (in %) of Singapore?
Ensure brevity in your answer.  0.8. What is the difference between the highest and the second highest Revenue generated (in %) of Ukraine?
Keep it short and to the point. 0.64. What is the difference between the highest and the second highest Revenue generated (in %) in Venezuela?
Provide a short and direct response. 0.58. What is the difference between the highest and the lowest Revenue generated (in %) in Hungary?
Provide a short and direct response. 7.01. What is the difference between the highest and the lowest Revenue generated (in %) in Singapore?
Your answer should be very brief. 1.55. What is the difference between the highest and the lowest Revenue generated (in %) in Ukraine?
Your answer should be very brief. 7.71. What is the difference between the highest and the lowest Revenue generated (in %) of Venezuela?
Your answer should be very brief. 9.71. 